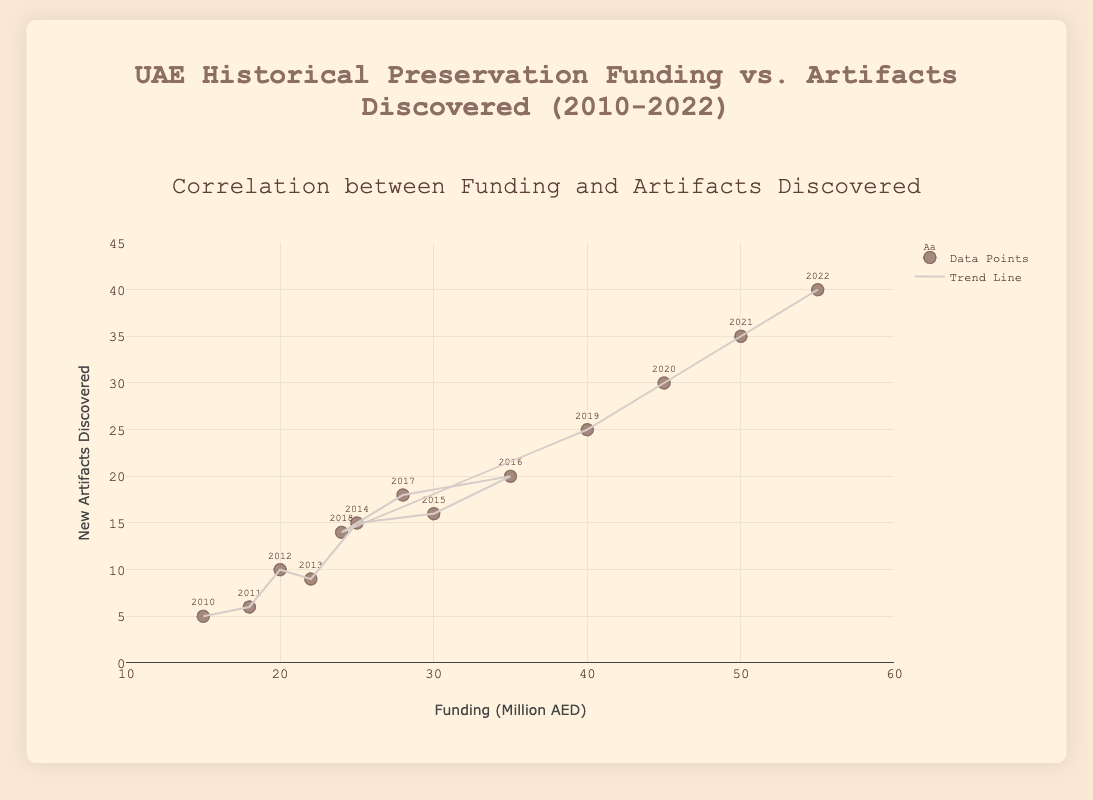What is the title of the plot? The title of the plot is always located at the top of the chart. In this case, the title is written in a larger font size and reads "UAE Historical Preservation Funding vs. Artifacts Discovered (2010-2022)".
Answer: UAE Historical Preservation Funding vs. Artifacts Discovered (2010-2022) How many data points are represented in the scatter plot? Each data point represents a year, shown as a marker with a text label indicating the year on the plot. By counting these points, one can see that there are 13 data points, each corresponding to a year from 2010 to 2022.
Answer: 13 What is the general trend observed in the relationship between funding and the number of artifacts discovered? The trend line shows a positive correlation, which means that as funding (in million AED) increases, the number of new artifacts discovered also tends to increase.
Answer: Positive correlation In which year was the funding the highest and how much was it? The marker labeled with the year 2022 is the highest on the x-axis, indicating the highest funding. The funding for that year is noted as 55 million AED.
Answer: 2022, 55 million AED How many new artifacts were discovered in the year with the highest funding? By identifying the highest funding year, 2022, and then checking the corresponding y-axis value, we can see that 40 new artifacts were discovered in that year.
Answer: 40 Compare the new artifacts discovered in 2015 and 2018. Which year saw more discoveries, and by how many? The data points for 2015 and 2018 show 16 and 14 new artifacts discovered respectively. By subtracting these values, we find that 2015 had 2 more discoveries than 2018.
Answer: 2015 by 2 What is the average number of new artifacts discovered from 2010 to 2022? Sum all the artifacts discovered over the years (5+6+10+9+15+16+20+18+14+25+30+35+40=243) and divide by the number of years (13). Therefore, the average is 243/13 ≈ 18.69.
Answer: 18.69 During which year did a dip in funding occur after a previous increase, and what was the funding amount that year? By checking the funding values sequentially, a decrease in funding can be seen in 2017 after an increase in 2016. The funding in 2017 was 28 million AED.
Answer: 2017, 28 million AED What can be inferred about the trend line's slope and its implication on historical artifact discovery efforts? The slope of the trend line is positive, indicating that as funding increases, more artifacts are likely to be discovered. This implies a direct relationship between financial investment in historical preservation and the number of new discoveries.
Answer: As funding increases, more artifacts are likely discovered 